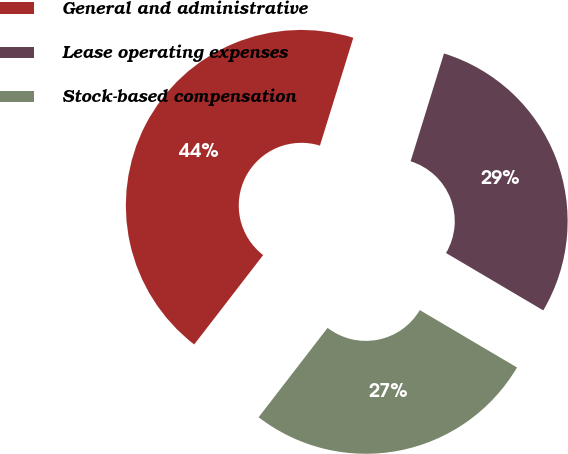Convert chart. <chart><loc_0><loc_0><loc_500><loc_500><pie_chart><fcel>General and administrative<fcel>Lease operating expenses<fcel>Stock-based compensation<nl><fcel>44.32%<fcel>28.71%<fcel>26.97%<nl></chart> 